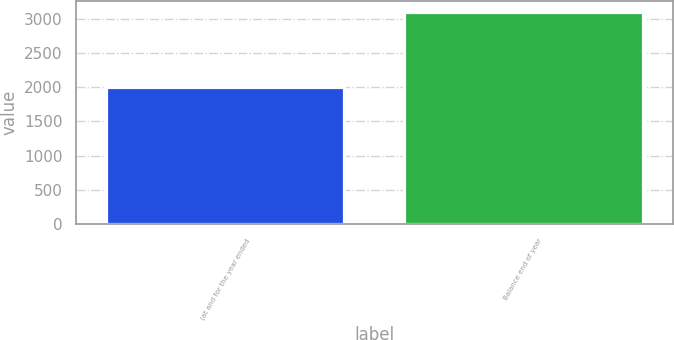Convert chart. <chart><loc_0><loc_0><loc_500><loc_500><bar_chart><fcel>(at and for the year ended<fcel>Balance end of year<nl><fcel>2012<fcel>3103<nl></chart> 